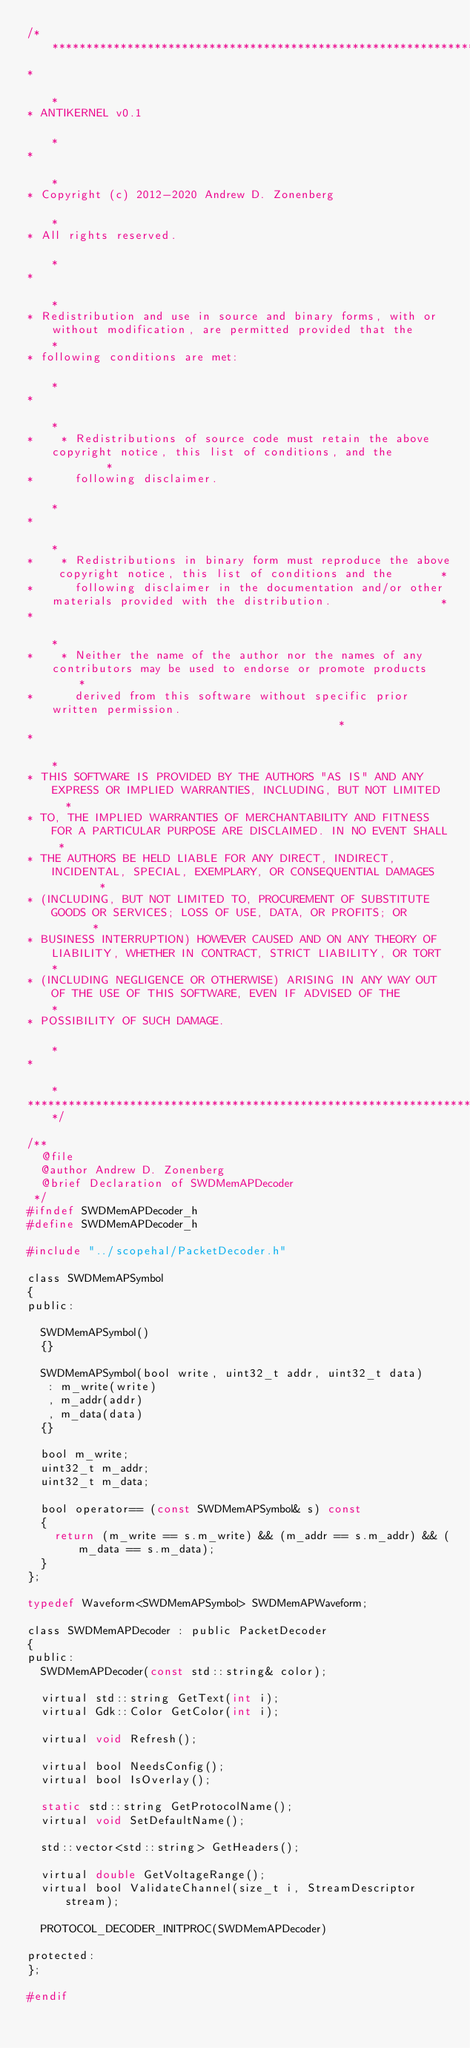<code> <loc_0><loc_0><loc_500><loc_500><_C_>/***********************************************************************************************************************
*                                                                                                                      *
* ANTIKERNEL v0.1                                                                                                      *
*                                                                                                                      *
* Copyright (c) 2012-2020 Andrew D. Zonenberg                                                                          *
* All rights reserved.                                                                                                 *
*                                                                                                                      *
* Redistribution and use in source and binary forms, with or without modification, are permitted provided that the     *
* following conditions are met:                                                                                        *
*                                                                                                                      *
*    * Redistributions of source code must retain the above copyright notice, this list of conditions, and the         *
*      following disclaimer.                                                                                           *
*                                                                                                                      *
*    * Redistributions in binary form must reproduce the above copyright notice, this list of conditions and the       *
*      following disclaimer in the documentation and/or other materials provided with the distribution.                *
*                                                                                                                      *
*    * Neither the name of the author nor the names of any contributors may be used to endorse or promote products     *
*      derived from this software without specific prior written permission.                                           *
*                                                                                                                      *
* THIS SOFTWARE IS PROVIDED BY THE AUTHORS "AS IS" AND ANY EXPRESS OR IMPLIED WARRANTIES, INCLUDING, BUT NOT LIMITED   *
* TO, THE IMPLIED WARRANTIES OF MERCHANTABILITY AND FITNESS FOR A PARTICULAR PURPOSE ARE DISCLAIMED. IN NO EVENT SHALL *
* THE AUTHORS BE HELD LIABLE FOR ANY DIRECT, INDIRECT, INCIDENTAL, SPECIAL, EXEMPLARY, OR CONSEQUENTIAL DAMAGES        *
* (INCLUDING, BUT NOT LIMITED TO, PROCUREMENT OF SUBSTITUTE GOODS OR SERVICES; LOSS OF USE, DATA, OR PROFITS; OR       *
* BUSINESS INTERRUPTION) HOWEVER CAUSED AND ON ANY THEORY OF LIABILITY, WHETHER IN CONTRACT, STRICT LIABILITY, OR TORT *
* (INCLUDING NEGLIGENCE OR OTHERWISE) ARISING IN ANY WAY OUT OF THE USE OF THIS SOFTWARE, EVEN IF ADVISED OF THE       *
* POSSIBILITY OF SUCH DAMAGE.                                                                                          *
*                                                                                                                      *
***********************************************************************************************************************/

/**
	@file
	@author Andrew D. Zonenberg
	@brief Declaration of SWDMemAPDecoder
 */
#ifndef SWDMemAPDecoder_h
#define SWDMemAPDecoder_h

#include "../scopehal/PacketDecoder.h"

class SWDMemAPSymbol
{
public:

	SWDMemAPSymbol()
	{}

	SWDMemAPSymbol(bool write, uint32_t addr, uint32_t data)
	 : m_write(write)
	 , m_addr(addr)
	 , m_data(data)
	{}

	bool m_write;
	uint32_t m_addr;
	uint32_t m_data;

	bool operator== (const SWDMemAPSymbol& s) const
	{
		return (m_write == s.m_write) && (m_addr == s.m_addr) && (m_data == s.m_data);
	}
};

typedef Waveform<SWDMemAPSymbol> SWDMemAPWaveform;

class SWDMemAPDecoder : public PacketDecoder
{
public:
	SWDMemAPDecoder(const std::string& color);

	virtual std::string GetText(int i);
	virtual Gdk::Color GetColor(int i);

	virtual void Refresh();

	virtual bool NeedsConfig();
	virtual bool IsOverlay();

	static std::string GetProtocolName();
	virtual void SetDefaultName();

	std::vector<std::string> GetHeaders();

	virtual double GetVoltageRange();
	virtual bool ValidateChannel(size_t i, StreamDescriptor stream);

	PROTOCOL_DECODER_INITPROC(SWDMemAPDecoder)

protected:
};

#endif
</code> 